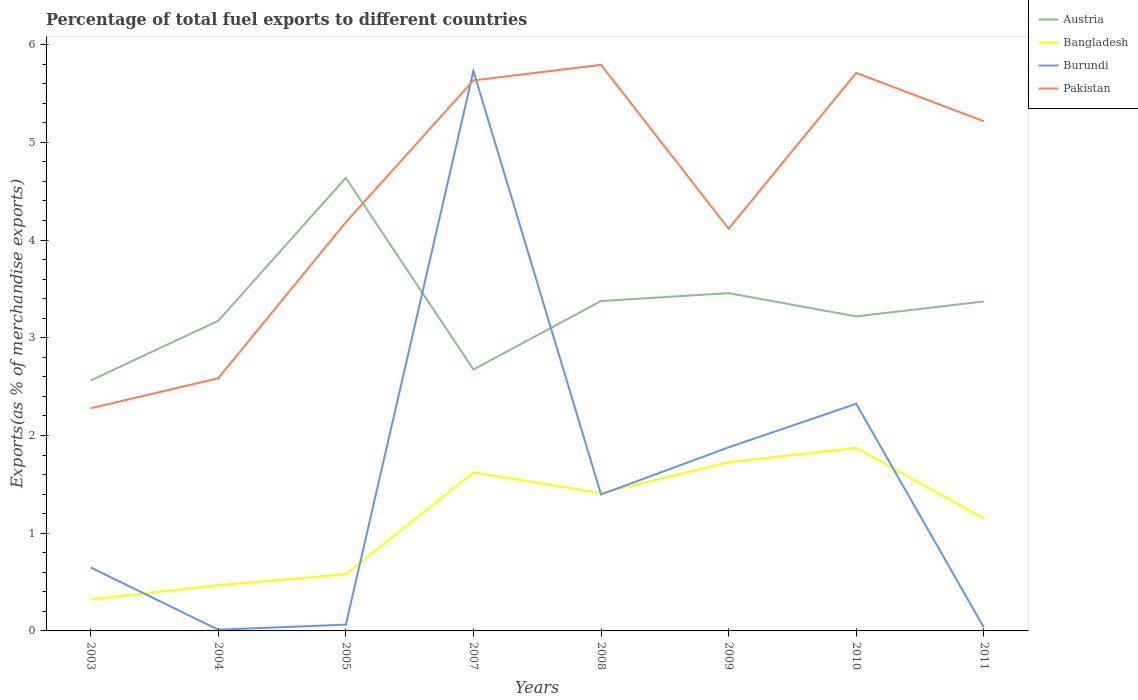Across all years, what is the maximum percentage of exports to different countries in Pakistan?
Offer a very short reply. 2.28. What is the total percentage of exports to different countries in Pakistan in the graph?
Offer a terse response. -1.03. What is the difference between the highest and the second highest percentage of exports to different countries in Austria?
Give a very brief answer. 2.07. What is the difference between the highest and the lowest percentage of exports to different countries in Austria?
Offer a very short reply. 4. Is the percentage of exports to different countries in Bangladesh strictly greater than the percentage of exports to different countries in Austria over the years?
Give a very brief answer. Yes. How many lines are there?
Provide a short and direct response. 4. How many years are there in the graph?
Keep it short and to the point. 8. Are the values on the major ticks of Y-axis written in scientific E-notation?
Keep it short and to the point. No. Does the graph contain any zero values?
Provide a succinct answer. No. Does the graph contain grids?
Your answer should be compact. No. What is the title of the graph?
Your response must be concise. Percentage of total fuel exports to different countries. What is the label or title of the X-axis?
Keep it short and to the point. Years. What is the label or title of the Y-axis?
Offer a terse response. Exports(as % of merchandise exports). What is the Exports(as % of merchandise exports) in Austria in 2003?
Offer a very short reply. 2.56. What is the Exports(as % of merchandise exports) in Bangladesh in 2003?
Your answer should be compact. 0.32. What is the Exports(as % of merchandise exports) in Burundi in 2003?
Your answer should be compact. 0.65. What is the Exports(as % of merchandise exports) of Pakistan in 2003?
Make the answer very short. 2.28. What is the Exports(as % of merchandise exports) in Austria in 2004?
Give a very brief answer. 3.17. What is the Exports(as % of merchandise exports) of Bangladesh in 2004?
Offer a terse response. 0.47. What is the Exports(as % of merchandise exports) of Burundi in 2004?
Your response must be concise. 0.01. What is the Exports(as % of merchandise exports) in Pakistan in 2004?
Provide a succinct answer. 2.59. What is the Exports(as % of merchandise exports) in Austria in 2005?
Your answer should be compact. 4.64. What is the Exports(as % of merchandise exports) of Bangladesh in 2005?
Offer a terse response. 0.58. What is the Exports(as % of merchandise exports) of Burundi in 2005?
Give a very brief answer. 0.06. What is the Exports(as % of merchandise exports) of Pakistan in 2005?
Your answer should be compact. 4.18. What is the Exports(as % of merchandise exports) of Austria in 2007?
Provide a short and direct response. 2.67. What is the Exports(as % of merchandise exports) in Bangladesh in 2007?
Keep it short and to the point. 1.62. What is the Exports(as % of merchandise exports) in Burundi in 2007?
Your response must be concise. 5.73. What is the Exports(as % of merchandise exports) in Pakistan in 2007?
Provide a short and direct response. 5.63. What is the Exports(as % of merchandise exports) in Austria in 2008?
Provide a short and direct response. 3.38. What is the Exports(as % of merchandise exports) of Bangladesh in 2008?
Offer a terse response. 1.41. What is the Exports(as % of merchandise exports) in Burundi in 2008?
Provide a short and direct response. 1.4. What is the Exports(as % of merchandise exports) in Pakistan in 2008?
Provide a succinct answer. 5.79. What is the Exports(as % of merchandise exports) in Austria in 2009?
Ensure brevity in your answer.  3.46. What is the Exports(as % of merchandise exports) of Bangladesh in 2009?
Your response must be concise. 1.73. What is the Exports(as % of merchandise exports) in Burundi in 2009?
Your response must be concise. 1.88. What is the Exports(as % of merchandise exports) in Pakistan in 2009?
Your response must be concise. 4.12. What is the Exports(as % of merchandise exports) in Austria in 2010?
Make the answer very short. 3.22. What is the Exports(as % of merchandise exports) in Bangladesh in 2010?
Your answer should be very brief. 1.87. What is the Exports(as % of merchandise exports) in Burundi in 2010?
Give a very brief answer. 2.32. What is the Exports(as % of merchandise exports) in Pakistan in 2010?
Make the answer very short. 5.71. What is the Exports(as % of merchandise exports) in Austria in 2011?
Offer a very short reply. 3.37. What is the Exports(as % of merchandise exports) of Bangladesh in 2011?
Provide a short and direct response. 1.15. What is the Exports(as % of merchandise exports) in Burundi in 2011?
Provide a short and direct response. 0.04. What is the Exports(as % of merchandise exports) of Pakistan in 2011?
Provide a short and direct response. 5.22. Across all years, what is the maximum Exports(as % of merchandise exports) in Austria?
Provide a short and direct response. 4.64. Across all years, what is the maximum Exports(as % of merchandise exports) of Bangladesh?
Your answer should be compact. 1.87. Across all years, what is the maximum Exports(as % of merchandise exports) of Burundi?
Offer a very short reply. 5.73. Across all years, what is the maximum Exports(as % of merchandise exports) in Pakistan?
Give a very brief answer. 5.79. Across all years, what is the minimum Exports(as % of merchandise exports) of Austria?
Offer a very short reply. 2.56. Across all years, what is the minimum Exports(as % of merchandise exports) in Bangladesh?
Ensure brevity in your answer.  0.32. Across all years, what is the minimum Exports(as % of merchandise exports) of Burundi?
Provide a succinct answer. 0.01. Across all years, what is the minimum Exports(as % of merchandise exports) in Pakistan?
Ensure brevity in your answer.  2.28. What is the total Exports(as % of merchandise exports) in Austria in the graph?
Keep it short and to the point. 26.47. What is the total Exports(as % of merchandise exports) in Bangladesh in the graph?
Your response must be concise. 9.16. What is the total Exports(as % of merchandise exports) of Burundi in the graph?
Offer a terse response. 12.09. What is the total Exports(as % of merchandise exports) in Pakistan in the graph?
Provide a succinct answer. 35.51. What is the difference between the Exports(as % of merchandise exports) in Austria in 2003 and that in 2004?
Provide a succinct answer. -0.61. What is the difference between the Exports(as % of merchandise exports) in Bangladesh in 2003 and that in 2004?
Keep it short and to the point. -0.15. What is the difference between the Exports(as % of merchandise exports) of Burundi in 2003 and that in 2004?
Keep it short and to the point. 0.64. What is the difference between the Exports(as % of merchandise exports) in Pakistan in 2003 and that in 2004?
Provide a succinct answer. -0.31. What is the difference between the Exports(as % of merchandise exports) of Austria in 2003 and that in 2005?
Provide a short and direct response. -2.07. What is the difference between the Exports(as % of merchandise exports) of Bangladesh in 2003 and that in 2005?
Give a very brief answer. -0.26. What is the difference between the Exports(as % of merchandise exports) in Burundi in 2003 and that in 2005?
Make the answer very short. 0.58. What is the difference between the Exports(as % of merchandise exports) of Pakistan in 2003 and that in 2005?
Provide a succinct answer. -1.9. What is the difference between the Exports(as % of merchandise exports) in Austria in 2003 and that in 2007?
Offer a very short reply. -0.11. What is the difference between the Exports(as % of merchandise exports) of Bangladesh in 2003 and that in 2007?
Your answer should be compact. -1.3. What is the difference between the Exports(as % of merchandise exports) in Burundi in 2003 and that in 2007?
Offer a very short reply. -5.08. What is the difference between the Exports(as % of merchandise exports) of Pakistan in 2003 and that in 2007?
Your response must be concise. -3.35. What is the difference between the Exports(as % of merchandise exports) in Austria in 2003 and that in 2008?
Offer a very short reply. -0.81. What is the difference between the Exports(as % of merchandise exports) in Bangladesh in 2003 and that in 2008?
Your response must be concise. -1.09. What is the difference between the Exports(as % of merchandise exports) in Burundi in 2003 and that in 2008?
Your answer should be very brief. -0.75. What is the difference between the Exports(as % of merchandise exports) in Pakistan in 2003 and that in 2008?
Make the answer very short. -3.51. What is the difference between the Exports(as % of merchandise exports) of Austria in 2003 and that in 2009?
Make the answer very short. -0.89. What is the difference between the Exports(as % of merchandise exports) in Bangladesh in 2003 and that in 2009?
Your answer should be compact. -1.4. What is the difference between the Exports(as % of merchandise exports) of Burundi in 2003 and that in 2009?
Make the answer very short. -1.23. What is the difference between the Exports(as % of merchandise exports) in Pakistan in 2003 and that in 2009?
Provide a short and direct response. -1.84. What is the difference between the Exports(as % of merchandise exports) in Austria in 2003 and that in 2010?
Give a very brief answer. -0.66. What is the difference between the Exports(as % of merchandise exports) of Bangladesh in 2003 and that in 2010?
Your answer should be compact. -1.55. What is the difference between the Exports(as % of merchandise exports) of Burundi in 2003 and that in 2010?
Offer a very short reply. -1.68. What is the difference between the Exports(as % of merchandise exports) of Pakistan in 2003 and that in 2010?
Provide a short and direct response. -3.43. What is the difference between the Exports(as % of merchandise exports) of Austria in 2003 and that in 2011?
Your answer should be compact. -0.81. What is the difference between the Exports(as % of merchandise exports) in Bangladesh in 2003 and that in 2011?
Offer a terse response. -0.83. What is the difference between the Exports(as % of merchandise exports) in Burundi in 2003 and that in 2011?
Keep it short and to the point. 0.61. What is the difference between the Exports(as % of merchandise exports) in Pakistan in 2003 and that in 2011?
Offer a terse response. -2.94. What is the difference between the Exports(as % of merchandise exports) in Austria in 2004 and that in 2005?
Make the answer very short. -1.46. What is the difference between the Exports(as % of merchandise exports) in Bangladesh in 2004 and that in 2005?
Give a very brief answer. -0.11. What is the difference between the Exports(as % of merchandise exports) of Burundi in 2004 and that in 2005?
Your answer should be very brief. -0.05. What is the difference between the Exports(as % of merchandise exports) in Pakistan in 2004 and that in 2005?
Offer a very short reply. -1.6. What is the difference between the Exports(as % of merchandise exports) of Austria in 2004 and that in 2007?
Give a very brief answer. 0.5. What is the difference between the Exports(as % of merchandise exports) in Bangladesh in 2004 and that in 2007?
Make the answer very short. -1.15. What is the difference between the Exports(as % of merchandise exports) in Burundi in 2004 and that in 2007?
Give a very brief answer. -5.72. What is the difference between the Exports(as % of merchandise exports) in Pakistan in 2004 and that in 2007?
Provide a succinct answer. -3.05. What is the difference between the Exports(as % of merchandise exports) in Austria in 2004 and that in 2008?
Ensure brevity in your answer.  -0.2. What is the difference between the Exports(as % of merchandise exports) in Bangladesh in 2004 and that in 2008?
Give a very brief answer. -0.94. What is the difference between the Exports(as % of merchandise exports) in Burundi in 2004 and that in 2008?
Make the answer very short. -1.38. What is the difference between the Exports(as % of merchandise exports) in Pakistan in 2004 and that in 2008?
Ensure brevity in your answer.  -3.21. What is the difference between the Exports(as % of merchandise exports) of Austria in 2004 and that in 2009?
Make the answer very short. -0.28. What is the difference between the Exports(as % of merchandise exports) of Bangladesh in 2004 and that in 2009?
Offer a terse response. -1.26. What is the difference between the Exports(as % of merchandise exports) in Burundi in 2004 and that in 2009?
Ensure brevity in your answer.  -1.87. What is the difference between the Exports(as % of merchandise exports) in Pakistan in 2004 and that in 2009?
Your response must be concise. -1.53. What is the difference between the Exports(as % of merchandise exports) of Austria in 2004 and that in 2010?
Offer a very short reply. -0.04. What is the difference between the Exports(as % of merchandise exports) of Bangladesh in 2004 and that in 2010?
Your response must be concise. -1.4. What is the difference between the Exports(as % of merchandise exports) in Burundi in 2004 and that in 2010?
Your answer should be very brief. -2.31. What is the difference between the Exports(as % of merchandise exports) in Pakistan in 2004 and that in 2010?
Offer a very short reply. -3.12. What is the difference between the Exports(as % of merchandise exports) in Austria in 2004 and that in 2011?
Give a very brief answer. -0.2. What is the difference between the Exports(as % of merchandise exports) of Bangladesh in 2004 and that in 2011?
Give a very brief answer. -0.68. What is the difference between the Exports(as % of merchandise exports) of Burundi in 2004 and that in 2011?
Keep it short and to the point. -0.02. What is the difference between the Exports(as % of merchandise exports) of Pakistan in 2004 and that in 2011?
Your answer should be compact. -2.63. What is the difference between the Exports(as % of merchandise exports) of Austria in 2005 and that in 2007?
Your answer should be compact. 1.96. What is the difference between the Exports(as % of merchandise exports) of Bangladesh in 2005 and that in 2007?
Give a very brief answer. -1.04. What is the difference between the Exports(as % of merchandise exports) in Burundi in 2005 and that in 2007?
Your response must be concise. -5.67. What is the difference between the Exports(as % of merchandise exports) in Pakistan in 2005 and that in 2007?
Offer a terse response. -1.45. What is the difference between the Exports(as % of merchandise exports) of Austria in 2005 and that in 2008?
Keep it short and to the point. 1.26. What is the difference between the Exports(as % of merchandise exports) in Bangladesh in 2005 and that in 2008?
Provide a succinct answer. -0.83. What is the difference between the Exports(as % of merchandise exports) of Burundi in 2005 and that in 2008?
Keep it short and to the point. -1.33. What is the difference between the Exports(as % of merchandise exports) of Pakistan in 2005 and that in 2008?
Give a very brief answer. -1.61. What is the difference between the Exports(as % of merchandise exports) of Austria in 2005 and that in 2009?
Provide a short and direct response. 1.18. What is the difference between the Exports(as % of merchandise exports) of Bangladesh in 2005 and that in 2009?
Your response must be concise. -1.15. What is the difference between the Exports(as % of merchandise exports) of Burundi in 2005 and that in 2009?
Give a very brief answer. -1.81. What is the difference between the Exports(as % of merchandise exports) of Pakistan in 2005 and that in 2009?
Give a very brief answer. 0.07. What is the difference between the Exports(as % of merchandise exports) of Austria in 2005 and that in 2010?
Keep it short and to the point. 1.42. What is the difference between the Exports(as % of merchandise exports) of Bangladesh in 2005 and that in 2010?
Give a very brief answer. -1.29. What is the difference between the Exports(as % of merchandise exports) of Burundi in 2005 and that in 2010?
Offer a very short reply. -2.26. What is the difference between the Exports(as % of merchandise exports) in Pakistan in 2005 and that in 2010?
Give a very brief answer. -1.53. What is the difference between the Exports(as % of merchandise exports) of Austria in 2005 and that in 2011?
Your answer should be compact. 1.27. What is the difference between the Exports(as % of merchandise exports) in Bangladesh in 2005 and that in 2011?
Make the answer very short. -0.57. What is the difference between the Exports(as % of merchandise exports) in Burundi in 2005 and that in 2011?
Keep it short and to the point. 0.03. What is the difference between the Exports(as % of merchandise exports) in Pakistan in 2005 and that in 2011?
Provide a succinct answer. -1.03. What is the difference between the Exports(as % of merchandise exports) of Austria in 2007 and that in 2008?
Make the answer very short. -0.7. What is the difference between the Exports(as % of merchandise exports) in Bangladesh in 2007 and that in 2008?
Provide a short and direct response. 0.21. What is the difference between the Exports(as % of merchandise exports) of Burundi in 2007 and that in 2008?
Your response must be concise. 4.33. What is the difference between the Exports(as % of merchandise exports) of Pakistan in 2007 and that in 2008?
Provide a short and direct response. -0.16. What is the difference between the Exports(as % of merchandise exports) in Austria in 2007 and that in 2009?
Ensure brevity in your answer.  -0.78. What is the difference between the Exports(as % of merchandise exports) in Bangladesh in 2007 and that in 2009?
Offer a very short reply. -0.1. What is the difference between the Exports(as % of merchandise exports) of Burundi in 2007 and that in 2009?
Offer a very short reply. 3.85. What is the difference between the Exports(as % of merchandise exports) in Pakistan in 2007 and that in 2009?
Offer a terse response. 1.52. What is the difference between the Exports(as % of merchandise exports) in Austria in 2007 and that in 2010?
Offer a very short reply. -0.54. What is the difference between the Exports(as % of merchandise exports) in Bangladesh in 2007 and that in 2010?
Offer a terse response. -0.25. What is the difference between the Exports(as % of merchandise exports) of Burundi in 2007 and that in 2010?
Your answer should be very brief. 3.41. What is the difference between the Exports(as % of merchandise exports) of Pakistan in 2007 and that in 2010?
Offer a very short reply. -0.08. What is the difference between the Exports(as % of merchandise exports) in Austria in 2007 and that in 2011?
Provide a short and direct response. -0.7. What is the difference between the Exports(as % of merchandise exports) of Bangladesh in 2007 and that in 2011?
Your response must be concise. 0.47. What is the difference between the Exports(as % of merchandise exports) in Burundi in 2007 and that in 2011?
Your response must be concise. 5.69. What is the difference between the Exports(as % of merchandise exports) of Pakistan in 2007 and that in 2011?
Provide a short and direct response. 0.42. What is the difference between the Exports(as % of merchandise exports) of Austria in 2008 and that in 2009?
Give a very brief answer. -0.08. What is the difference between the Exports(as % of merchandise exports) in Bangladesh in 2008 and that in 2009?
Offer a terse response. -0.32. What is the difference between the Exports(as % of merchandise exports) in Burundi in 2008 and that in 2009?
Your response must be concise. -0.48. What is the difference between the Exports(as % of merchandise exports) in Pakistan in 2008 and that in 2009?
Provide a succinct answer. 1.68. What is the difference between the Exports(as % of merchandise exports) of Austria in 2008 and that in 2010?
Offer a terse response. 0.16. What is the difference between the Exports(as % of merchandise exports) in Bangladesh in 2008 and that in 2010?
Your answer should be compact. -0.46. What is the difference between the Exports(as % of merchandise exports) in Burundi in 2008 and that in 2010?
Your answer should be compact. -0.93. What is the difference between the Exports(as % of merchandise exports) of Pakistan in 2008 and that in 2010?
Your response must be concise. 0.08. What is the difference between the Exports(as % of merchandise exports) of Austria in 2008 and that in 2011?
Ensure brevity in your answer.  0. What is the difference between the Exports(as % of merchandise exports) of Bangladesh in 2008 and that in 2011?
Give a very brief answer. 0.26. What is the difference between the Exports(as % of merchandise exports) of Burundi in 2008 and that in 2011?
Give a very brief answer. 1.36. What is the difference between the Exports(as % of merchandise exports) in Pakistan in 2008 and that in 2011?
Offer a terse response. 0.58. What is the difference between the Exports(as % of merchandise exports) in Austria in 2009 and that in 2010?
Offer a terse response. 0.24. What is the difference between the Exports(as % of merchandise exports) of Bangladesh in 2009 and that in 2010?
Offer a terse response. -0.15. What is the difference between the Exports(as % of merchandise exports) in Burundi in 2009 and that in 2010?
Ensure brevity in your answer.  -0.45. What is the difference between the Exports(as % of merchandise exports) in Pakistan in 2009 and that in 2010?
Your answer should be very brief. -1.59. What is the difference between the Exports(as % of merchandise exports) of Austria in 2009 and that in 2011?
Offer a very short reply. 0.09. What is the difference between the Exports(as % of merchandise exports) of Bangladesh in 2009 and that in 2011?
Give a very brief answer. 0.57. What is the difference between the Exports(as % of merchandise exports) of Burundi in 2009 and that in 2011?
Make the answer very short. 1.84. What is the difference between the Exports(as % of merchandise exports) in Pakistan in 2009 and that in 2011?
Keep it short and to the point. -1.1. What is the difference between the Exports(as % of merchandise exports) of Austria in 2010 and that in 2011?
Provide a short and direct response. -0.15. What is the difference between the Exports(as % of merchandise exports) of Bangladesh in 2010 and that in 2011?
Ensure brevity in your answer.  0.72. What is the difference between the Exports(as % of merchandise exports) in Burundi in 2010 and that in 2011?
Provide a short and direct response. 2.29. What is the difference between the Exports(as % of merchandise exports) in Pakistan in 2010 and that in 2011?
Provide a succinct answer. 0.49. What is the difference between the Exports(as % of merchandise exports) of Austria in 2003 and the Exports(as % of merchandise exports) of Bangladesh in 2004?
Your answer should be very brief. 2.09. What is the difference between the Exports(as % of merchandise exports) in Austria in 2003 and the Exports(as % of merchandise exports) in Burundi in 2004?
Give a very brief answer. 2.55. What is the difference between the Exports(as % of merchandise exports) in Austria in 2003 and the Exports(as % of merchandise exports) in Pakistan in 2004?
Your answer should be compact. -0.02. What is the difference between the Exports(as % of merchandise exports) of Bangladesh in 2003 and the Exports(as % of merchandise exports) of Burundi in 2004?
Keep it short and to the point. 0.31. What is the difference between the Exports(as % of merchandise exports) in Bangladesh in 2003 and the Exports(as % of merchandise exports) in Pakistan in 2004?
Ensure brevity in your answer.  -2.26. What is the difference between the Exports(as % of merchandise exports) in Burundi in 2003 and the Exports(as % of merchandise exports) in Pakistan in 2004?
Make the answer very short. -1.94. What is the difference between the Exports(as % of merchandise exports) in Austria in 2003 and the Exports(as % of merchandise exports) in Bangladesh in 2005?
Ensure brevity in your answer.  1.98. What is the difference between the Exports(as % of merchandise exports) of Austria in 2003 and the Exports(as % of merchandise exports) of Burundi in 2005?
Offer a very short reply. 2.5. What is the difference between the Exports(as % of merchandise exports) in Austria in 2003 and the Exports(as % of merchandise exports) in Pakistan in 2005?
Offer a very short reply. -1.62. What is the difference between the Exports(as % of merchandise exports) in Bangladesh in 2003 and the Exports(as % of merchandise exports) in Burundi in 2005?
Ensure brevity in your answer.  0.26. What is the difference between the Exports(as % of merchandise exports) in Bangladesh in 2003 and the Exports(as % of merchandise exports) in Pakistan in 2005?
Your answer should be compact. -3.86. What is the difference between the Exports(as % of merchandise exports) of Burundi in 2003 and the Exports(as % of merchandise exports) of Pakistan in 2005?
Offer a very short reply. -3.53. What is the difference between the Exports(as % of merchandise exports) of Austria in 2003 and the Exports(as % of merchandise exports) of Bangladesh in 2007?
Your answer should be compact. 0.94. What is the difference between the Exports(as % of merchandise exports) in Austria in 2003 and the Exports(as % of merchandise exports) in Burundi in 2007?
Give a very brief answer. -3.17. What is the difference between the Exports(as % of merchandise exports) in Austria in 2003 and the Exports(as % of merchandise exports) in Pakistan in 2007?
Give a very brief answer. -3.07. What is the difference between the Exports(as % of merchandise exports) of Bangladesh in 2003 and the Exports(as % of merchandise exports) of Burundi in 2007?
Ensure brevity in your answer.  -5.41. What is the difference between the Exports(as % of merchandise exports) in Bangladesh in 2003 and the Exports(as % of merchandise exports) in Pakistan in 2007?
Ensure brevity in your answer.  -5.31. What is the difference between the Exports(as % of merchandise exports) of Burundi in 2003 and the Exports(as % of merchandise exports) of Pakistan in 2007?
Ensure brevity in your answer.  -4.98. What is the difference between the Exports(as % of merchandise exports) in Austria in 2003 and the Exports(as % of merchandise exports) in Bangladesh in 2008?
Your answer should be very brief. 1.15. What is the difference between the Exports(as % of merchandise exports) in Austria in 2003 and the Exports(as % of merchandise exports) in Burundi in 2008?
Give a very brief answer. 1.17. What is the difference between the Exports(as % of merchandise exports) in Austria in 2003 and the Exports(as % of merchandise exports) in Pakistan in 2008?
Your answer should be compact. -3.23. What is the difference between the Exports(as % of merchandise exports) in Bangladesh in 2003 and the Exports(as % of merchandise exports) in Burundi in 2008?
Your response must be concise. -1.07. What is the difference between the Exports(as % of merchandise exports) of Bangladesh in 2003 and the Exports(as % of merchandise exports) of Pakistan in 2008?
Provide a short and direct response. -5.47. What is the difference between the Exports(as % of merchandise exports) in Burundi in 2003 and the Exports(as % of merchandise exports) in Pakistan in 2008?
Provide a succinct answer. -5.14. What is the difference between the Exports(as % of merchandise exports) of Austria in 2003 and the Exports(as % of merchandise exports) of Bangladesh in 2009?
Provide a short and direct response. 0.84. What is the difference between the Exports(as % of merchandise exports) of Austria in 2003 and the Exports(as % of merchandise exports) of Burundi in 2009?
Ensure brevity in your answer.  0.68. What is the difference between the Exports(as % of merchandise exports) in Austria in 2003 and the Exports(as % of merchandise exports) in Pakistan in 2009?
Ensure brevity in your answer.  -1.55. What is the difference between the Exports(as % of merchandise exports) of Bangladesh in 2003 and the Exports(as % of merchandise exports) of Burundi in 2009?
Your response must be concise. -1.56. What is the difference between the Exports(as % of merchandise exports) in Bangladesh in 2003 and the Exports(as % of merchandise exports) in Pakistan in 2009?
Give a very brief answer. -3.79. What is the difference between the Exports(as % of merchandise exports) of Burundi in 2003 and the Exports(as % of merchandise exports) of Pakistan in 2009?
Offer a very short reply. -3.47. What is the difference between the Exports(as % of merchandise exports) of Austria in 2003 and the Exports(as % of merchandise exports) of Bangladesh in 2010?
Provide a short and direct response. 0.69. What is the difference between the Exports(as % of merchandise exports) in Austria in 2003 and the Exports(as % of merchandise exports) in Burundi in 2010?
Make the answer very short. 0.24. What is the difference between the Exports(as % of merchandise exports) of Austria in 2003 and the Exports(as % of merchandise exports) of Pakistan in 2010?
Your answer should be compact. -3.15. What is the difference between the Exports(as % of merchandise exports) of Bangladesh in 2003 and the Exports(as % of merchandise exports) of Burundi in 2010?
Provide a short and direct response. -2. What is the difference between the Exports(as % of merchandise exports) in Bangladesh in 2003 and the Exports(as % of merchandise exports) in Pakistan in 2010?
Provide a succinct answer. -5.39. What is the difference between the Exports(as % of merchandise exports) in Burundi in 2003 and the Exports(as % of merchandise exports) in Pakistan in 2010?
Provide a short and direct response. -5.06. What is the difference between the Exports(as % of merchandise exports) of Austria in 2003 and the Exports(as % of merchandise exports) of Bangladesh in 2011?
Your response must be concise. 1.41. What is the difference between the Exports(as % of merchandise exports) in Austria in 2003 and the Exports(as % of merchandise exports) in Burundi in 2011?
Provide a short and direct response. 2.53. What is the difference between the Exports(as % of merchandise exports) in Austria in 2003 and the Exports(as % of merchandise exports) in Pakistan in 2011?
Offer a terse response. -2.65. What is the difference between the Exports(as % of merchandise exports) of Bangladesh in 2003 and the Exports(as % of merchandise exports) of Burundi in 2011?
Offer a terse response. 0.29. What is the difference between the Exports(as % of merchandise exports) of Bangladesh in 2003 and the Exports(as % of merchandise exports) of Pakistan in 2011?
Make the answer very short. -4.89. What is the difference between the Exports(as % of merchandise exports) in Burundi in 2003 and the Exports(as % of merchandise exports) in Pakistan in 2011?
Provide a succinct answer. -4.57. What is the difference between the Exports(as % of merchandise exports) of Austria in 2004 and the Exports(as % of merchandise exports) of Bangladesh in 2005?
Offer a terse response. 2.59. What is the difference between the Exports(as % of merchandise exports) in Austria in 2004 and the Exports(as % of merchandise exports) in Burundi in 2005?
Provide a short and direct response. 3.11. What is the difference between the Exports(as % of merchandise exports) in Austria in 2004 and the Exports(as % of merchandise exports) in Pakistan in 2005?
Your answer should be very brief. -1.01. What is the difference between the Exports(as % of merchandise exports) of Bangladesh in 2004 and the Exports(as % of merchandise exports) of Burundi in 2005?
Provide a short and direct response. 0.4. What is the difference between the Exports(as % of merchandise exports) in Bangladesh in 2004 and the Exports(as % of merchandise exports) in Pakistan in 2005?
Provide a short and direct response. -3.71. What is the difference between the Exports(as % of merchandise exports) of Burundi in 2004 and the Exports(as % of merchandise exports) of Pakistan in 2005?
Give a very brief answer. -4.17. What is the difference between the Exports(as % of merchandise exports) of Austria in 2004 and the Exports(as % of merchandise exports) of Bangladesh in 2007?
Keep it short and to the point. 1.55. What is the difference between the Exports(as % of merchandise exports) of Austria in 2004 and the Exports(as % of merchandise exports) of Burundi in 2007?
Give a very brief answer. -2.56. What is the difference between the Exports(as % of merchandise exports) in Austria in 2004 and the Exports(as % of merchandise exports) in Pakistan in 2007?
Provide a succinct answer. -2.46. What is the difference between the Exports(as % of merchandise exports) of Bangladesh in 2004 and the Exports(as % of merchandise exports) of Burundi in 2007?
Your response must be concise. -5.26. What is the difference between the Exports(as % of merchandise exports) of Bangladesh in 2004 and the Exports(as % of merchandise exports) of Pakistan in 2007?
Your response must be concise. -5.16. What is the difference between the Exports(as % of merchandise exports) in Burundi in 2004 and the Exports(as % of merchandise exports) in Pakistan in 2007?
Your answer should be very brief. -5.62. What is the difference between the Exports(as % of merchandise exports) in Austria in 2004 and the Exports(as % of merchandise exports) in Bangladesh in 2008?
Offer a terse response. 1.76. What is the difference between the Exports(as % of merchandise exports) of Austria in 2004 and the Exports(as % of merchandise exports) of Burundi in 2008?
Provide a short and direct response. 1.78. What is the difference between the Exports(as % of merchandise exports) of Austria in 2004 and the Exports(as % of merchandise exports) of Pakistan in 2008?
Offer a terse response. -2.62. What is the difference between the Exports(as % of merchandise exports) of Bangladesh in 2004 and the Exports(as % of merchandise exports) of Burundi in 2008?
Your answer should be very brief. -0.93. What is the difference between the Exports(as % of merchandise exports) in Bangladesh in 2004 and the Exports(as % of merchandise exports) in Pakistan in 2008?
Your answer should be very brief. -5.32. What is the difference between the Exports(as % of merchandise exports) of Burundi in 2004 and the Exports(as % of merchandise exports) of Pakistan in 2008?
Offer a terse response. -5.78. What is the difference between the Exports(as % of merchandise exports) of Austria in 2004 and the Exports(as % of merchandise exports) of Bangladesh in 2009?
Give a very brief answer. 1.45. What is the difference between the Exports(as % of merchandise exports) in Austria in 2004 and the Exports(as % of merchandise exports) in Burundi in 2009?
Provide a succinct answer. 1.3. What is the difference between the Exports(as % of merchandise exports) of Austria in 2004 and the Exports(as % of merchandise exports) of Pakistan in 2009?
Provide a succinct answer. -0.94. What is the difference between the Exports(as % of merchandise exports) of Bangladesh in 2004 and the Exports(as % of merchandise exports) of Burundi in 2009?
Offer a terse response. -1.41. What is the difference between the Exports(as % of merchandise exports) in Bangladesh in 2004 and the Exports(as % of merchandise exports) in Pakistan in 2009?
Give a very brief answer. -3.65. What is the difference between the Exports(as % of merchandise exports) in Burundi in 2004 and the Exports(as % of merchandise exports) in Pakistan in 2009?
Offer a very short reply. -4.1. What is the difference between the Exports(as % of merchandise exports) in Austria in 2004 and the Exports(as % of merchandise exports) in Bangladesh in 2010?
Offer a very short reply. 1.3. What is the difference between the Exports(as % of merchandise exports) of Austria in 2004 and the Exports(as % of merchandise exports) of Burundi in 2010?
Provide a succinct answer. 0.85. What is the difference between the Exports(as % of merchandise exports) in Austria in 2004 and the Exports(as % of merchandise exports) in Pakistan in 2010?
Provide a succinct answer. -2.54. What is the difference between the Exports(as % of merchandise exports) in Bangladesh in 2004 and the Exports(as % of merchandise exports) in Burundi in 2010?
Your response must be concise. -1.86. What is the difference between the Exports(as % of merchandise exports) in Bangladesh in 2004 and the Exports(as % of merchandise exports) in Pakistan in 2010?
Your answer should be compact. -5.24. What is the difference between the Exports(as % of merchandise exports) of Burundi in 2004 and the Exports(as % of merchandise exports) of Pakistan in 2010?
Offer a terse response. -5.7. What is the difference between the Exports(as % of merchandise exports) in Austria in 2004 and the Exports(as % of merchandise exports) in Bangladesh in 2011?
Your answer should be very brief. 2.02. What is the difference between the Exports(as % of merchandise exports) of Austria in 2004 and the Exports(as % of merchandise exports) of Burundi in 2011?
Keep it short and to the point. 3.14. What is the difference between the Exports(as % of merchandise exports) in Austria in 2004 and the Exports(as % of merchandise exports) in Pakistan in 2011?
Your response must be concise. -2.04. What is the difference between the Exports(as % of merchandise exports) of Bangladesh in 2004 and the Exports(as % of merchandise exports) of Burundi in 2011?
Keep it short and to the point. 0.43. What is the difference between the Exports(as % of merchandise exports) of Bangladesh in 2004 and the Exports(as % of merchandise exports) of Pakistan in 2011?
Ensure brevity in your answer.  -4.75. What is the difference between the Exports(as % of merchandise exports) of Burundi in 2004 and the Exports(as % of merchandise exports) of Pakistan in 2011?
Your response must be concise. -5.2. What is the difference between the Exports(as % of merchandise exports) of Austria in 2005 and the Exports(as % of merchandise exports) of Bangladesh in 2007?
Ensure brevity in your answer.  3.01. What is the difference between the Exports(as % of merchandise exports) of Austria in 2005 and the Exports(as % of merchandise exports) of Burundi in 2007?
Give a very brief answer. -1.09. What is the difference between the Exports(as % of merchandise exports) of Austria in 2005 and the Exports(as % of merchandise exports) of Pakistan in 2007?
Offer a very short reply. -1. What is the difference between the Exports(as % of merchandise exports) in Bangladesh in 2005 and the Exports(as % of merchandise exports) in Burundi in 2007?
Provide a short and direct response. -5.15. What is the difference between the Exports(as % of merchandise exports) in Bangladesh in 2005 and the Exports(as % of merchandise exports) in Pakistan in 2007?
Provide a short and direct response. -5.05. What is the difference between the Exports(as % of merchandise exports) in Burundi in 2005 and the Exports(as % of merchandise exports) in Pakistan in 2007?
Offer a terse response. -5.57. What is the difference between the Exports(as % of merchandise exports) of Austria in 2005 and the Exports(as % of merchandise exports) of Bangladesh in 2008?
Keep it short and to the point. 3.23. What is the difference between the Exports(as % of merchandise exports) of Austria in 2005 and the Exports(as % of merchandise exports) of Burundi in 2008?
Provide a succinct answer. 3.24. What is the difference between the Exports(as % of merchandise exports) of Austria in 2005 and the Exports(as % of merchandise exports) of Pakistan in 2008?
Offer a terse response. -1.16. What is the difference between the Exports(as % of merchandise exports) of Bangladesh in 2005 and the Exports(as % of merchandise exports) of Burundi in 2008?
Offer a terse response. -0.82. What is the difference between the Exports(as % of merchandise exports) of Bangladesh in 2005 and the Exports(as % of merchandise exports) of Pakistan in 2008?
Offer a terse response. -5.21. What is the difference between the Exports(as % of merchandise exports) in Burundi in 2005 and the Exports(as % of merchandise exports) in Pakistan in 2008?
Provide a succinct answer. -5.73. What is the difference between the Exports(as % of merchandise exports) of Austria in 2005 and the Exports(as % of merchandise exports) of Bangladesh in 2009?
Give a very brief answer. 2.91. What is the difference between the Exports(as % of merchandise exports) in Austria in 2005 and the Exports(as % of merchandise exports) in Burundi in 2009?
Your response must be concise. 2.76. What is the difference between the Exports(as % of merchandise exports) in Austria in 2005 and the Exports(as % of merchandise exports) in Pakistan in 2009?
Ensure brevity in your answer.  0.52. What is the difference between the Exports(as % of merchandise exports) in Bangladesh in 2005 and the Exports(as % of merchandise exports) in Burundi in 2009?
Your answer should be very brief. -1.3. What is the difference between the Exports(as % of merchandise exports) of Bangladesh in 2005 and the Exports(as % of merchandise exports) of Pakistan in 2009?
Give a very brief answer. -3.54. What is the difference between the Exports(as % of merchandise exports) of Burundi in 2005 and the Exports(as % of merchandise exports) of Pakistan in 2009?
Provide a succinct answer. -4.05. What is the difference between the Exports(as % of merchandise exports) of Austria in 2005 and the Exports(as % of merchandise exports) of Bangladesh in 2010?
Offer a terse response. 2.76. What is the difference between the Exports(as % of merchandise exports) in Austria in 2005 and the Exports(as % of merchandise exports) in Burundi in 2010?
Provide a succinct answer. 2.31. What is the difference between the Exports(as % of merchandise exports) of Austria in 2005 and the Exports(as % of merchandise exports) of Pakistan in 2010?
Ensure brevity in your answer.  -1.07. What is the difference between the Exports(as % of merchandise exports) in Bangladesh in 2005 and the Exports(as % of merchandise exports) in Burundi in 2010?
Keep it short and to the point. -1.74. What is the difference between the Exports(as % of merchandise exports) in Bangladesh in 2005 and the Exports(as % of merchandise exports) in Pakistan in 2010?
Your answer should be compact. -5.13. What is the difference between the Exports(as % of merchandise exports) in Burundi in 2005 and the Exports(as % of merchandise exports) in Pakistan in 2010?
Ensure brevity in your answer.  -5.65. What is the difference between the Exports(as % of merchandise exports) of Austria in 2005 and the Exports(as % of merchandise exports) of Bangladesh in 2011?
Ensure brevity in your answer.  3.48. What is the difference between the Exports(as % of merchandise exports) of Austria in 2005 and the Exports(as % of merchandise exports) of Burundi in 2011?
Give a very brief answer. 4.6. What is the difference between the Exports(as % of merchandise exports) of Austria in 2005 and the Exports(as % of merchandise exports) of Pakistan in 2011?
Give a very brief answer. -0.58. What is the difference between the Exports(as % of merchandise exports) in Bangladesh in 2005 and the Exports(as % of merchandise exports) in Burundi in 2011?
Offer a terse response. 0.54. What is the difference between the Exports(as % of merchandise exports) in Bangladesh in 2005 and the Exports(as % of merchandise exports) in Pakistan in 2011?
Your response must be concise. -4.64. What is the difference between the Exports(as % of merchandise exports) of Burundi in 2005 and the Exports(as % of merchandise exports) of Pakistan in 2011?
Provide a short and direct response. -5.15. What is the difference between the Exports(as % of merchandise exports) of Austria in 2007 and the Exports(as % of merchandise exports) of Bangladesh in 2008?
Provide a short and direct response. 1.26. What is the difference between the Exports(as % of merchandise exports) in Austria in 2007 and the Exports(as % of merchandise exports) in Burundi in 2008?
Provide a succinct answer. 1.28. What is the difference between the Exports(as % of merchandise exports) of Austria in 2007 and the Exports(as % of merchandise exports) of Pakistan in 2008?
Ensure brevity in your answer.  -3.12. What is the difference between the Exports(as % of merchandise exports) in Bangladesh in 2007 and the Exports(as % of merchandise exports) in Burundi in 2008?
Provide a short and direct response. 0.23. What is the difference between the Exports(as % of merchandise exports) in Bangladesh in 2007 and the Exports(as % of merchandise exports) in Pakistan in 2008?
Provide a short and direct response. -4.17. What is the difference between the Exports(as % of merchandise exports) in Burundi in 2007 and the Exports(as % of merchandise exports) in Pakistan in 2008?
Make the answer very short. -0.06. What is the difference between the Exports(as % of merchandise exports) in Austria in 2007 and the Exports(as % of merchandise exports) in Bangladesh in 2009?
Offer a very short reply. 0.95. What is the difference between the Exports(as % of merchandise exports) in Austria in 2007 and the Exports(as % of merchandise exports) in Burundi in 2009?
Give a very brief answer. 0.8. What is the difference between the Exports(as % of merchandise exports) of Austria in 2007 and the Exports(as % of merchandise exports) of Pakistan in 2009?
Make the answer very short. -1.44. What is the difference between the Exports(as % of merchandise exports) in Bangladesh in 2007 and the Exports(as % of merchandise exports) in Burundi in 2009?
Provide a short and direct response. -0.26. What is the difference between the Exports(as % of merchandise exports) of Bangladesh in 2007 and the Exports(as % of merchandise exports) of Pakistan in 2009?
Make the answer very short. -2.49. What is the difference between the Exports(as % of merchandise exports) of Burundi in 2007 and the Exports(as % of merchandise exports) of Pakistan in 2009?
Offer a terse response. 1.61. What is the difference between the Exports(as % of merchandise exports) in Austria in 2007 and the Exports(as % of merchandise exports) in Bangladesh in 2010?
Give a very brief answer. 0.8. What is the difference between the Exports(as % of merchandise exports) in Austria in 2007 and the Exports(as % of merchandise exports) in Burundi in 2010?
Provide a short and direct response. 0.35. What is the difference between the Exports(as % of merchandise exports) in Austria in 2007 and the Exports(as % of merchandise exports) in Pakistan in 2010?
Provide a short and direct response. -3.03. What is the difference between the Exports(as % of merchandise exports) of Bangladesh in 2007 and the Exports(as % of merchandise exports) of Burundi in 2010?
Your answer should be compact. -0.7. What is the difference between the Exports(as % of merchandise exports) of Bangladesh in 2007 and the Exports(as % of merchandise exports) of Pakistan in 2010?
Your answer should be compact. -4.09. What is the difference between the Exports(as % of merchandise exports) in Burundi in 2007 and the Exports(as % of merchandise exports) in Pakistan in 2010?
Your answer should be compact. 0.02. What is the difference between the Exports(as % of merchandise exports) in Austria in 2007 and the Exports(as % of merchandise exports) in Bangladesh in 2011?
Your answer should be compact. 1.52. What is the difference between the Exports(as % of merchandise exports) in Austria in 2007 and the Exports(as % of merchandise exports) in Burundi in 2011?
Provide a succinct answer. 2.64. What is the difference between the Exports(as % of merchandise exports) of Austria in 2007 and the Exports(as % of merchandise exports) of Pakistan in 2011?
Your response must be concise. -2.54. What is the difference between the Exports(as % of merchandise exports) of Bangladesh in 2007 and the Exports(as % of merchandise exports) of Burundi in 2011?
Give a very brief answer. 1.59. What is the difference between the Exports(as % of merchandise exports) in Bangladesh in 2007 and the Exports(as % of merchandise exports) in Pakistan in 2011?
Ensure brevity in your answer.  -3.59. What is the difference between the Exports(as % of merchandise exports) in Burundi in 2007 and the Exports(as % of merchandise exports) in Pakistan in 2011?
Your response must be concise. 0.51. What is the difference between the Exports(as % of merchandise exports) of Austria in 2008 and the Exports(as % of merchandise exports) of Bangladesh in 2009?
Offer a very short reply. 1.65. What is the difference between the Exports(as % of merchandise exports) of Austria in 2008 and the Exports(as % of merchandise exports) of Burundi in 2009?
Provide a short and direct response. 1.5. What is the difference between the Exports(as % of merchandise exports) in Austria in 2008 and the Exports(as % of merchandise exports) in Pakistan in 2009?
Your answer should be compact. -0.74. What is the difference between the Exports(as % of merchandise exports) in Bangladesh in 2008 and the Exports(as % of merchandise exports) in Burundi in 2009?
Your answer should be very brief. -0.47. What is the difference between the Exports(as % of merchandise exports) in Bangladesh in 2008 and the Exports(as % of merchandise exports) in Pakistan in 2009?
Give a very brief answer. -2.7. What is the difference between the Exports(as % of merchandise exports) in Burundi in 2008 and the Exports(as % of merchandise exports) in Pakistan in 2009?
Your response must be concise. -2.72. What is the difference between the Exports(as % of merchandise exports) of Austria in 2008 and the Exports(as % of merchandise exports) of Bangladesh in 2010?
Your response must be concise. 1.5. What is the difference between the Exports(as % of merchandise exports) of Austria in 2008 and the Exports(as % of merchandise exports) of Burundi in 2010?
Keep it short and to the point. 1.05. What is the difference between the Exports(as % of merchandise exports) in Austria in 2008 and the Exports(as % of merchandise exports) in Pakistan in 2010?
Offer a terse response. -2.33. What is the difference between the Exports(as % of merchandise exports) of Bangladesh in 2008 and the Exports(as % of merchandise exports) of Burundi in 2010?
Ensure brevity in your answer.  -0.91. What is the difference between the Exports(as % of merchandise exports) in Bangladesh in 2008 and the Exports(as % of merchandise exports) in Pakistan in 2010?
Keep it short and to the point. -4.3. What is the difference between the Exports(as % of merchandise exports) of Burundi in 2008 and the Exports(as % of merchandise exports) of Pakistan in 2010?
Offer a very short reply. -4.31. What is the difference between the Exports(as % of merchandise exports) in Austria in 2008 and the Exports(as % of merchandise exports) in Bangladesh in 2011?
Provide a short and direct response. 2.22. What is the difference between the Exports(as % of merchandise exports) of Austria in 2008 and the Exports(as % of merchandise exports) of Burundi in 2011?
Offer a terse response. 3.34. What is the difference between the Exports(as % of merchandise exports) of Austria in 2008 and the Exports(as % of merchandise exports) of Pakistan in 2011?
Offer a very short reply. -1.84. What is the difference between the Exports(as % of merchandise exports) of Bangladesh in 2008 and the Exports(as % of merchandise exports) of Burundi in 2011?
Your answer should be compact. 1.37. What is the difference between the Exports(as % of merchandise exports) in Bangladesh in 2008 and the Exports(as % of merchandise exports) in Pakistan in 2011?
Your answer should be very brief. -3.81. What is the difference between the Exports(as % of merchandise exports) in Burundi in 2008 and the Exports(as % of merchandise exports) in Pakistan in 2011?
Make the answer very short. -3.82. What is the difference between the Exports(as % of merchandise exports) in Austria in 2009 and the Exports(as % of merchandise exports) in Bangladesh in 2010?
Your answer should be very brief. 1.58. What is the difference between the Exports(as % of merchandise exports) in Austria in 2009 and the Exports(as % of merchandise exports) in Burundi in 2010?
Provide a succinct answer. 1.13. What is the difference between the Exports(as % of merchandise exports) in Austria in 2009 and the Exports(as % of merchandise exports) in Pakistan in 2010?
Keep it short and to the point. -2.25. What is the difference between the Exports(as % of merchandise exports) of Bangladesh in 2009 and the Exports(as % of merchandise exports) of Burundi in 2010?
Your answer should be very brief. -0.6. What is the difference between the Exports(as % of merchandise exports) of Bangladesh in 2009 and the Exports(as % of merchandise exports) of Pakistan in 2010?
Keep it short and to the point. -3.98. What is the difference between the Exports(as % of merchandise exports) of Burundi in 2009 and the Exports(as % of merchandise exports) of Pakistan in 2010?
Provide a succinct answer. -3.83. What is the difference between the Exports(as % of merchandise exports) of Austria in 2009 and the Exports(as % of merchandise exports) of Bangladesh in 2011?
Your answer should be compact. 2.3. What is the difference between the Exports(as % of merchandise exports) in Austria in 2009 and the Exports(as % of merchandise exports) in Burundi in 2011?
Provide a short and direct response. 3.42. What is the difference between the Exports(as % of merchandise exports) in Austria in 2009 and the Exports(as % of merchandise exports) in Pakistan in 2011?
Provide a succinct answer. -1.76. What is the difference between the Exports(as % of merchandise exports) of Bangladesh in 2009 and the Exports(as % of merchandise exports) of Burundi in 2011?
Your response must be concise. 1.69. What is the difference between the Exports(as % of merchandise exports) in Bangladesh in 2009 and the Exports(as % of merchandise exports) in Pakistan in 2011?
Offer a very short reply. -3.49. What is the difference between the Exports(as % of merchandise exports) of Burundi in 2009 and the Exports(as % of merchandise exports) of Pakistan in 2011?
Offer a terse response. -3.34. What is the difference between the Exports(as % of merchandise exports) of Austria in 2010 and the Exports(as % of merchandise exports) of Bangladesh in 2011?
Provide a succinct answer. 2.07. What is the difference between the Exports(as % of merchandise exports) of Austria in 2010 and the Exports(as % of merchandise exports) of Burundi in 2011?
Your answer should be very brief. 3.18. What is the difference between the Exports(as % of merchandise exports) in Austria in 2010 and the Exports(as % of merchandise exports) in Pakistan in 2011?
Give a very brief answer. -2. What is the difference between the Exports(as % of merchandise exports) of Bangladesh in 2010 and the Exports(as % of merchandise exports) of Burundi in 2011?
Your answer should be compact. 1.84. What is the difference between the Exports(as % of merchandise exports) of Bangladesh in 2010 and the Exports(as % of merchandise exports) of Pakistan in 2011?
Your response must be concise. -3.34. What is the difference between the Exports(as % of merchandise exports) of Burundi in 2010 and the Exports(as % of merchandise exports) of Pakistan in 2011?
Give a very brief answer. -2.89. What is the average Exports(as % of merchandise exports) of Austria per year?
Offer a terse response. 3.31. What is the average Exports(as % of merchandise exports) of Bangladesh per year?
Ensure brevity in your answer.  1.14. What is the average Exports(as % of merchandise exports) of Burundi per year?
Offer a terse response. 1.51. What is the average Exports(as % of merchandise exports) in Pakistan per year?
Your response must be concise. 4.44. In the year 2003, what is the difference between the Exports(as % of merchandise exports) of Austria and Exports(as % of merchandise exports) of Bangladesh?
Make the answer very short. 2.24. In the year 2003, what is the difference between the Exports(as % of merchandise exports) in Austria and Exports(as % of merchandise exports) in Burundi?
Provide a short and direct response. 1.91. In the year 2003, what is the difference between the Exports(as % of merchandise exports) of Austria and Exports(as % of merchandise exports) of Pakistan?
Offer a terse response. 0.28. In the year 2003, what is the difference between the Exports(as % of merchandise exports) of Bangladesh and Exports(as % of merchandise exports) of Burundi?
Ensure brevity in your answer.  -0.33. In the year 2003, what is the difference between the Exports(as % of merchandise exports) of Bangladesh and Exports(as % of merchandise exports) of Pakistan?
Your answer should be very brief. -1.96. In the year 2003, what is the difference between the Exports(as % of merchandise exports) of Burundi and Exports(as % of merchandise exports) of Pakistan?
Offer a very short reply. -1.63. In the year 2004, what is the difference between the Exports(as % of merchandise exports) of Austria and Exports(as % of merchandise exports) of Bangladesh?
Ensure brevity in your answer.  2.71. In the year 2004, what is the difference between the Exports(as % of merchandise exports) in Austria and Exports(as % of merchandise exports) in Burundi?
Provide a short and direct response. 3.16. In the year 2004, what is the difference between the Exports(as % of merchandise exports) of Austria and Exports(as % of merchandise exports) of Pakistan?
Give a very brief answer. 0.59. In the year 2004, what is the difference between the Exports(as % of merchandise exports) in Bangladesh and Exports(as % of merchandise exports) in Burundi?
Offer a very short reply. 0.46. In the year 2004, what is the difference between the Exports(as % of merchandise exports) in Bangladesh and Exports(as % of merchandise exports) in Pakistan?
Keep it short and to the point. -2.12. In the year 2004, what is the difference between the Exports(as % of merchandise exports) of Burundi and Exports(as % of merchandise exports) of Pakistan?
Provide a short and direct response. -2.57. In the year 2005, what is the difference between the Exports(as % of merchandise exports) in Austria and Exports(as % of merchandise exports) in Bangladesh?
Offer a very short reply. 4.06. In the year 2005, what is the difference between the Exports(as % of merchandise exports) in Austria and Exports(as % of merchandise exports) in Burundi?
Offer a very short reply. 4.57. In the year 2005, what is the difference between the Exports(as % of merchandise exports) of Austria and Exports(as % of merchandise exports) of Pakistan?
Your response must be concise. 0.45. In the year 2005, what is the difference between the Exports(as % of merchandise exports) in Bangladesh and Exports(as % of merchandise exports) in Burundi?
Keep it short and to the point. 0.52. In the year 2005, what is the difference between the Exports(as % of merchandise exports) in Bangladesh and Exports(as % of merchandise exports) in Pakistan?
Give a very brief answer. -3.6. In the year 2005, what is the difference between the Exports(as % of merchandise exports) in Burundi and Exports(as % of merchandise exports) in Pakistan?
Make the answer very short. -4.12. In the year 2007, what is the difference between the Exports(as % of merchandise exports) in Austria and Exports(as % of merchandise exports) in Bangladesh?
Offer a terse response. 1.05. In the year 2007, what is the difference between the Exports(as % of merchandise exports) in Austria and Exports(as % of merchandise exports) in Burundi?
Your answer should be very brief. -3.05. In the year 2007, what is the difference between the Exports(as % of merchandise exports) in Austria and Exports(as % of merchandise exports) in Pakistan?
Keep it short and to the point. -2.96. In the year 2007, what is the difference between the Exports(as % of merchandise exports) in Bangladesh and Exports(as % of merchandise exports) in Burundi?
Give a very brief answer. -4.11. In the year 2007, what is the difference between the Exports(as % of merchandise exports) in Bangladesh and Exports(as % of merchandise exports) in Pakistan?
Your response must be concise. -4.01. In the year 2007, what is the difference between the Exports(as % of merchandise exports) in Burundi and Exports(as % of merchandise exports) in Pakistan?
Give a very brief answer. 0.1. In the year 2008, what is the difference between the Exports(as % of merchandise exports) of Austria and Exports(as % of merchandise exports) of Bangladesh?
Ensure brevity in your answer.  1.97. In the year 2008, what is the difference between the Exports(as % of merchandise exports) of Austria and Exports(as % of merchandise exports) of Burundi?
Provide a succinct answer. 1.98. In the year 2008, what is the difference between the Exports(as % of merchandise exports) in Austria and Exports(as % of merchandise exports) in Pakistan?
Provide a succinct answer. -2.42. In the year 2008, what is the difference between the Exports(as % of merchandise exports) of Bangladesh and Exports(as % of merchandise exports) of Burundi?
Make the answer very short. 0.01. In the year 2008, what is the difference between the Exports(as % of merchandise exports) of Bangladesh and Exports(as % of merchandise exports) of Pakistan?
Provide a short and direct response. -4.38. In the year 2008, what is the difference between the Exports(as % of merchandise exports) in Burundi and Exports(as % of merchandise exports) in Pakistan?
Keep it short and to the point. -4.4. In the year 2009, what is the difference between the Exports(as % of merchandise exports) of Austria and Exports(as % of merchandise exports) of Bangladesh?
Offer a terse response. 1.73. In the year 2009, what is the difference between the Exports(as % of merchandise exports) in Austria and Exports(as % of merchandise exports) in Burundi?
Provide a succinct answer. 1.58. In the year 2009, what is the difference between the Exports(as % of merchandise exports) of Austria and Exports(as % of merchandise exports) of Pakistan?
Give a very brief answer. -0.66. In the year 2009, what is the difference between the Exports(as % of merchandise exports) of Bangladesh and Exports(as % of merchandise exports) of Burundi?
Provide a short and direct response. -0.15. In the year 2009, what is the difference between the Exports(as % of merchandise exports) of Bangladesh and Exports(as % of merchandise exports) of Pakistan?
Ensure brevity in your answer.  -2.39. In the year 2009, what is the difference between the Exports(as % of merchandise exports) of Burundi and Exports(as % of merchandise exports) of Pakistan?
Offer a very short reply. -2.24. In the year 2010, what is the difference between the Exports(as % of merchandise exports) of Austria and Exports(as % of merchandise exports) of Bangladesh?
Provide a succinct answer. 1.35. In the year 2010, what is the difference between the Exports(as % of merchandise exports) in Austria and Exports(as % of merchandise exports) in Burundi?
Keep it short and to the point. 0.89. In the year 2010, what is the difference between the Exports(as % of merchandise exports) of Austria and Exports(as % of merchandise exports) of Pakistan?
Give a very brief answer. -2.49. In the year 2010, what is the difference between the Exports(as % of merchandise exports) in Bangladesh and Exports(as % of merchandise exports) in Burundi?
Make the answer very short. -0.45. In the year 2010, what is the difference between the Exports(as % of merchandise exports) of Bangladesh and Exports(as % of merchandise exports) of Pakistan?
Provide a short and direct response. -3.84. In the year 2010, what is the difference between the Exports(as % of merchandise exports) of Burundi and Exports(as % of merchandise exports) of Pakistan?
Provide a short and direct response. -3.39. In the year 2011, what is the difference between the Exports(as % of merchandise exports) of Austria and Exports(as % of merchandise exports) of Bangladesh?
Provide a short and direct response. 2.22. In the year 2011, what is the difference between the Exports(as % of merchandise exports) in Austria and Exports(as % of merchandise exports) in Burundi?
Offer a very short reply. 3.34. In the year 2011, what is the difference between the Exports(as % of merchandise exports) in Austria and Exports(as % of merchandise exports) in Pakistan?
Give a very brief answer. -1.84. In the year 2011, what is the difference between the Exports(as % of merchandise exports) of Bangladesh and Exports(as % of merchandise exports) of Burundi?
Give a very brief answer. 1.12. In the year 2011, what is the difference between the Exports(as % of merchandise exports) of Bangladesh and Exports(as % of merchandise exports) of Pakistan?
Ensure brevity in your answer.  -4.06. In the year 2011, what is the difference between the Exports(as % of merchandise exports) in Burundi and Exports(as % of merchandise exports) in Pakistan?
Ensure brevity in your answer.  -5.18. What is the ratio of the Exports(as % of merchandise exports) in Austria in 2003 to that in 2004?
Ensure brevity in your answer.  0.81. What is the ratio of the Exports(as % of merchandise exports) of Bangladesh in 2003 to that in 2004?
Give a very brief answer. 0.69. What is the ratio of the Exports(as % of merchandise exports) in Burundi in 2003 to that in 2004?
Ensure brevity in your answer.  51.92. What is the ratio of the Exports(as % of merchandise exports) of Pakistan in 2003 to that in 2004?
Provide a succinct answer. 0.88. What is the ratio of the Exports(as % of merchandise exports) of Austria in 2003 to that in 2005?
Offer a very short reply. 0.55. What is the ratio of the Exports(as % of merchandise exports) in Bangladesh in 2003 to that in 2005?
Your answer should be compact. 0.56. What is the ratio of the Exports(as % of merchandise exports) in Burundi in 2003 to that in 2005?
Give a very brief answer. 10.1. What is the ratio of the Exports(as % of merchandise exports) of Pakistan in 2003 to that in 2005?
Offer a very short reply. 0.54. What is the ratio of the Exports(as % of merchandise exports) in Austria in 2003 to that in 2007?
Ensure brevity in your answer.  0.96. What is the ratio of the Exports(as % of merchandise exports) in Bangladesh in 2003 to that in 2007?
Your answer should be very brief. 0.2. What is the ratio of the Exports(as % of merchandise exports) of Burundi in 2003 to that in 2007?
Offer a terse response. 0.11. What is the ratio of the Exports(as % of merchandise exports) in Pakistan in 2003 to that in 2007?
Ensure brevity in your answer.  0.4. What is the ratio of the Exports(as % of merchandise exports) of Austria in 2003 to that in 2008?
Keep it short and to the point. 0.76. What is the ratio of the Exports(as % of merchandise exports) of Bangladesh in 2003 to that in 2008?
Give a very brief answer. 0.23. What is the ratio of the Exports(as % of merchandise exports) in Burundi in 2003 to that in 2008?
Your answer should be very brief. 0.47. What is the ratio of the Exports(as % of merchandise exports) in Pakistan in 2003 to that in 2008?
Provide a short and direct response. 0.39. What is the ratio of the Exports(as % of merchandise exports) of Austria in 2003 to that in 2009?
Your response must be concise. 0.74. What is the ratio of the Exports(as % of merchandise exports) of Bangladesh in 2003 to that in 2009?
Your answer should be very brief. 0.19. What is the ratio of the Exports(as % of merchandise exports) in Burundi in 2003 to that in 2009?
Your response must be concise. 0.35. What is the ratio of the Exports(as % of merchandise exports) of Pakistan in 2003 to that in 2009?
Your answer should be compact. 0.55. What is the ratio of the Exports(as % of merchandise exports) of Austria in 2003 to that in 2010?
Make the answer very short. 0.8. What is the ratio of the Exports(as % of merchandise exports) of Bangladesh in 2003 to that in 2010?
Provide a succinct answer. 0.17. What is the ratio of the Exports(as % of merchandise exports) of Burundi in 2003 to that in 2010?
Ensure brevity in your answer.  0.28. What is the ratio of the Exports(as % of merchandise exports) of Pakistan in 2003 to that in 2010?
Your answer should be very brief. 0.4. What is the ratio of the Exports(as % of merchandise exports) of Austria in 2003 to that in 2011?
Ensure brevity in your answer.  0.76. What is the ratio of the Exports(as % of merchandise exports) in Bangladesh in 2003 to that in 2011?
Offer a terse response. 0.28. What is the ratio of the Exports(as % of merchandise exports) of Burundi in 2003 to that in 2011?
Provide a short and direct response. 17.93. What is the ratio of the Exports(as % of merchandise exports) of Pakistan in 2003 to that in 2011?
Ensure brevity in your answer.  0.44. What is the ratio of the Exports(as % of merchandise exports) in Austria in 2004 to that in 2005?
Your response must be concise. 0.68. What is the ratio of the Exports(as % of merchandise exports) in Bangladesh in 2004 to that in 2005?
Make the answer very short. 0.81. What is the ratio of the Exports(as % of merchandise exports) in Burundi in 2004 to that in 2005?
Your answer should be compact. 0.19. What is the ratio of the Exports(as % of merchandise exports) in Pakistan in 2004 to that in 2005?
Offer a very short reply. 0.62. What is the ratio of the Exports(as % of merchandise exports) of Austria in 2004 to that in 2007?
Make the answer very short. 1.19. What is the ratio of the Exports(as % of merchandise exports) of Bangladesh in 2004 to that in 2007?
Provide a succinct answer. 0.29. What is the ratio of the Exports(as % of merchandise exports) in Burundi in 2004 to that in 2007?
Provide a short and direct response. 0. What is the ratio of the Exports(as % of merchandise exports) of Pakistan in 2004 to that in 2007?
Your response must be concise. 0.46. What is the ratio of the Exports(as % of merchandise exports) in Austria in 2004 to that in 2008?
Your answer should be compact. 0.94. What is the ratio of the Exports(as % of merchandise exports) of Bangladesh in 2004 to that in 2008?
Provide a succinct answer. 0.33. What is the ratio of the Exports(as % of merchandise exports) of Burundi in 2004 to that in 2008?
Offer a terse response. 0.01. What is the ratio of the Exports(as % of merchandise exports) in Pakistan in 2004 to that in 2008?
Provide a short and direct response. 0.45. What is the ratio of the Exports(as % of merchandise exports) of Austria in 2004 to that in 2009?
Your answer should be very brief. 0.92. What is the ratio of the Exports(as % of merchandise exports) of Bangladesh in 2004 to that in 2009?
Your answer should be compact. 0.27. What is the ratio of the Exports(as % of merchandise exports) of Burundi in 2004 to that in 2009?
Give a very brief answer. 0.01. What is the ratio of the Exports(as % of merchandise exports) in Pakistan in 2004 to that in 2009?
Keep it short and to the point. 0.63. What is the ratio of the Exports(as % of merchandise exports) in Austria in 2004 to that in 2010?
Provide a succinct answer. 0.99. What is the ratio of the Exports(as % of merchandise exports) of Bangladesh in 2004 to that in 2010?
Keep it short and to the point. 0.25. What is the ratio of the Exports(as % of merchandise exports) in Burundi in 2004 to that in 2010?
Your answer should be compact. 0.01. What is the ratio of the Exports(as % of merchandise exports) of Pakistan in 2004 to that in 2010?
Ensure brevity in your answer.  0.45. What is the ratio of the Exports(as % of merchandise exports) in Austria in 2004 to that in 2011?
Make the answer very short. 0.94. What is the ratio of the Exports(as % of merchandise exports) of Bangladesh in 2004 to that in 2011?
Your answer should be very brief. 0.41. What is the ratio of the Exports(as % of merchandise exports) of Burundi in 2004 to that in 2011?
Make the answer very short. 0.35. What is the ratio of the Exports(as % of merchandise exports) of Pakistan in 2004 to that in 2011?
Provide a short and direct response. 0.5. What is the ratio of the Exports(as % of merchandise exports) of Austria in 2005 to that in 2007?
Offer a terse response. 1.73. What is the ratio of the Exports(as % of merchandise exports) in Bangladesh in 2005 to that in 2007?
Your response must be concise. 0.36. What is the ratio of the Exports(as % of merchandise exports) in Burundi in 2005 to that in 2007?
Offer a terse response. 0.01. What is the ratio of the Exports(as % of merchandise exports) of Pakistan in 2005 to that in 2007?
Provide a succinct answer. 0.74. What is the ratio of the Exports(as % of merchandise exports) in Austria in 2005 to that in 2008?
Provide a short and direct response. 1.37. What is the ratio of the Exports(as % of merchandise exports) in Bangladesh in 2005 to that in 2008?
Ensure brevity in your answer.  0.41. What is the ratio of the Exports(as % of merchandise exports) of Burundi in 2005 to that in 2008?
Make the answer very short. 0.05. What is the ratio of the Exports(as % of merchandise exports) of Pakistan in 2005 to that in 2008?
Your answer should be compact. 0.72. What is the ratio of the Exports(as % of merchandise exports) in Austria in 2005 to that in 2009?
Provide a short and direct response. 1.34. What is the ratio of the Exports(as % of merchandise exports) in Bangladesh in 2005 to that in 2009?
Offer a terse response. 0.34. What is the ratio of the Exports(as % of merchandise exports) of Burundi in 2005 to that in 2009?
Offer a terse response. 0.03. What is the ratio of the Exports(as % of merchandise exports) of Pakistan in 2005 to that in 2009?
Your answer should be very brief. 1.02. What is the ratio of the Exports(as % of merchandise exports) of Austria in 2005 to that in 2010?
Give a very brief answer. 1.44. What is the ratio of the Exports(as % of merchandise exports) in Bangladesh in 2005 to that in 2010?
Ensure brevity in your answer.  0.31. What is the ratio of the Exports(as % of merchandise exports) in Burundi in 2005 to that in 2010?
Make the answer very short. 0.03. What is the ratio of the Exports(as % of merchandise exports) of Pakistan in 2005 to that in 2010?
Make the answer very short. 0.73. What is the ratio of the Exports(as % of merchandise exports) in Austria in 2005 to that in 2011?
Keep it short and to the point. 1.38. What is the ratio of the Exports(as % of merchandise exports) in Bangladesh in 2005 to that in 2011?
Your answer should be compact. 0.5. What is the ratio of the Exports(as % of merchandise exports) of Burundi in 2005 to that in 2011?
Give a very brief answer. 1.77. What is the ratio of the Exports(as % of merchandise exports) in Pakistan in 2005 to that in 2011?
Your answer should be very brief. 0.8. What is the ratio of the Exports(as % of merchandise exports) of Austria in 2007 to that in 2008?
Your answer should be compact. 0.79. What is the ratio of the Exports(as % of merchandise exports) in Bangladesh in 2007 to that in 2008?
Make the answer very short. 1.15. What is the ratio of the Exports(as % of merchandise exports) in Burundi in 2007 to that in 2008?
Make the answer very short. 4.1. What is the ratio of the Exports(as % of merchandise exports) in Pakistan in 2007 to that in 2008?
Offer a very short reply. 0.97. What is the ratio of the Exports(as % of merchandise exports) in Austria in 2007 to that in 2009?
Your answer should be very brief. 0.77. What is the ratio of the Exports(as % of merchandise exports) of Burundi in 2007 to that in 2009?
Your answer should be very brief. 3.05. What is the ratio of the Exports(as % of merchandise exports) of Pakistan in 2007 to that in 2009?
Your answer should be compact. 1.37. What is the ratio of the Exports(as % of merchandise exports) in Austria in 2007 to that in 2010?
Provide a succinct answer. 0.83. What is the ratio of the Exports(as % of merchandise exports) of Bangladesh in 2007 to that in 2010?
Provide a succinct answer. 0.87. What is the ratio of the Exports(as % of merchandise exports) of Burundi in 2007 to that in 2010?
Your answer should be compact. 2.47. What is the ratio of the Exports(as % of merchandise exports) in Pakistan in 2007 to that in 2010?
Offer a very short reply. 0.99. What is the ratio of the Exports(as % of merchandise exports) in Austria in 2007 to that in 2011?
Your answer should be compact. 0.79. What is the ratio of the Exports(as % of merchandise exports) in Bangladesh in 2007 to that in 2011?
Make the answer very short. 1.41. What is the ratio of the Exports(as % of merchandise exports) in Burundi in 2007 to that in 2011?
Ensure brevity in your answer.  158.2. What is the ratio of the Exports(as % of merchandise exports) of Pakistan in 2007 to that in 2011?
Make the answer very short. 1.08. What is the ratio of the Exports(as % of merchandise exports) of Austria in 2008 to that in 2009?
Keep it short and to the point. 0.98. What is the ratio of the Exports(as % of merchandise exports) in Bangladesh in 2008 to that in 2009?
Offer a terse response. 0.82. What is the ratio of the Exports(as % of merchandise exports) of Burundi in 2008 to that in 2009?
Provide a short and direct response. 0.74. What is the ratio of the Exports(as % of merchandise exports) of Pakistan in 2008 to that in 2009?
Give a very brief answer. 1.41. What is the ratio of the Exports(as % of merchandise exports) in Austria in 2008 to that in 2010?
Keep it short and to the point. 1.05. What is the ratio of the Exports(as % of merchandise exports) of Bangladesh in 2008 to that in 2010?
Provide a succinct answer. 0.75. What is the ratio of the Exports(as % of merchandise exports) of Burundi in 2008 to that in 2010?
Your answer should be compact. 0.6. What is the ratio of the Exports(as % of merchandise exports) in Pakistan in 2008 to that in 2010?
Your answer should be very brief. 1.01. What is the ratio of the Exports(as % of merchandise exports) of Bangladesh in 2008 to that in 2011?
Provide a short and direct response. 1.22. What is the ratio of the Exports(as % of merchandise exports) in Burundi in 2008 to that in 2011?
Your response must be concise. 38.55. What is the ratio of the Exports(as % of merchandise exports) of Pakistan in 2008 to that in 2011?
Provide a succinct answer. 1.11. What is the ratio of the Exports(as % of merchandise exports) of Austria in 2009 to that in 2010?
Offer a very short reply. 1.07. What is the ratio of the Exports(as % of merchandise exports) in Bangladesh in 2009 to that in 2010?
Provide a short and direct response. 0.92. What is the ratio of the Exports(as % of merchandise exports) in Burundi in 2009 to that in 2010?
Your answer should be compact. 0.81. What is the ratio of the Exports(as % of merchandise exports) of Pakistan in 2009 to that in 2010?
Your answer should be compact. 0.72. What is the ratio of the Exports(as % of merchandise exports) of Austria in 2009 to that in 2011?
Offer a very short reply. 1.03. What is the ratio of the Exports(as % of merchandise exports) in Bangladesh in 2009 to that in 2011?
Your response must be concise. 1.5. What is the ratio of the Exports(as % of merchandise exports) in Burundi in 2009 to that in 2011?
Provide a succinct answer. 51.87. What is the ratio of the Exports(as % of merchandise exports) in Pakistan in 2009 to that in 2011?
Provide a succinct answer. 0.79. What is the ratio of the Exports(as % of merchandise exports) in Austria in 2010 to that in 2011?
Ensure brevity in your answer.  0.95. What is the ratio of the Exports(as % of merchandise exports) of Bangladesh in 2010 to that in 2011?
Your response must be concise. 1.63. What is the ratio of the Exports(as % of merchandise exports) of Burundi in 2010 to that in 2011?
Keep it short and to the point. 64.18. What is the ratio of the Exports(as % of merchandise exports) of Pakistan in 2010 to that in 2011?
Keep it short and to the point. 1.09. What is the difference between the highest and the second highest Exports(as % of merchandise exports) of Austria?
Your answer should be compact. 1.18. What is the difference between the highest and the second highest Exports(as % of merchandise exports) of Bangladesh?
Ensure brevity in your answer.  0.15. What is the difference between the highest and the second highest Exports(as % of merchandise exports) in Burundi?
Offer a very short reply. 3.41. What is the difference between the highest and the second highest Exports(as % of merchandise exports) in Pakistan?
Provide a succinct answer. 0.08. What is the difference between the highest and the lowest Exports(as % of merchandise exports) of Austria?
Your answer should be compact. 2.07. What is the difference between the highest and the lowest Exports(as % of merchandise exports) in Bangladesh?
Ensure brevity in your answer.  1.55. What is the difference between the highest and the lowest Exports(as % of merchandise exports) of Burundi?
Ensure brevity in your answer.  5.72. What is the difference between the highest and the lowest Exports(as % of merchandise exports) of Pakistan?
Offer a very short reply. 3.51. 